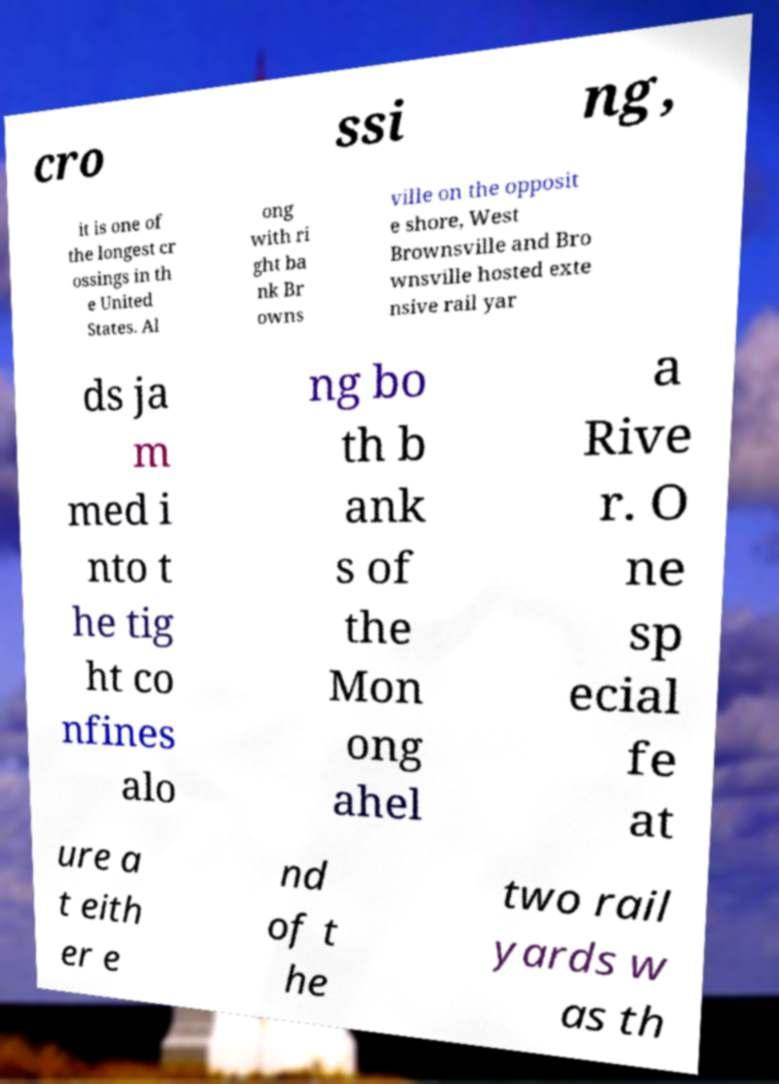Please identify and transcribe the text found in this image. cro ssi ng, it is one of the longest cr ossings in th e United States. Al ong with ri ght ba nk Br owns ville on the opposit e shore, West Brownsville and Bro wnsville hosted exte nsive rail yar ds ja m med i nto t he tig ht co nfines alo ng bo th b ank s of the Mon ong ahel a Rive r. O ne sp ecial fe at ure a t eith er e nd of t he two rail yards w as th 